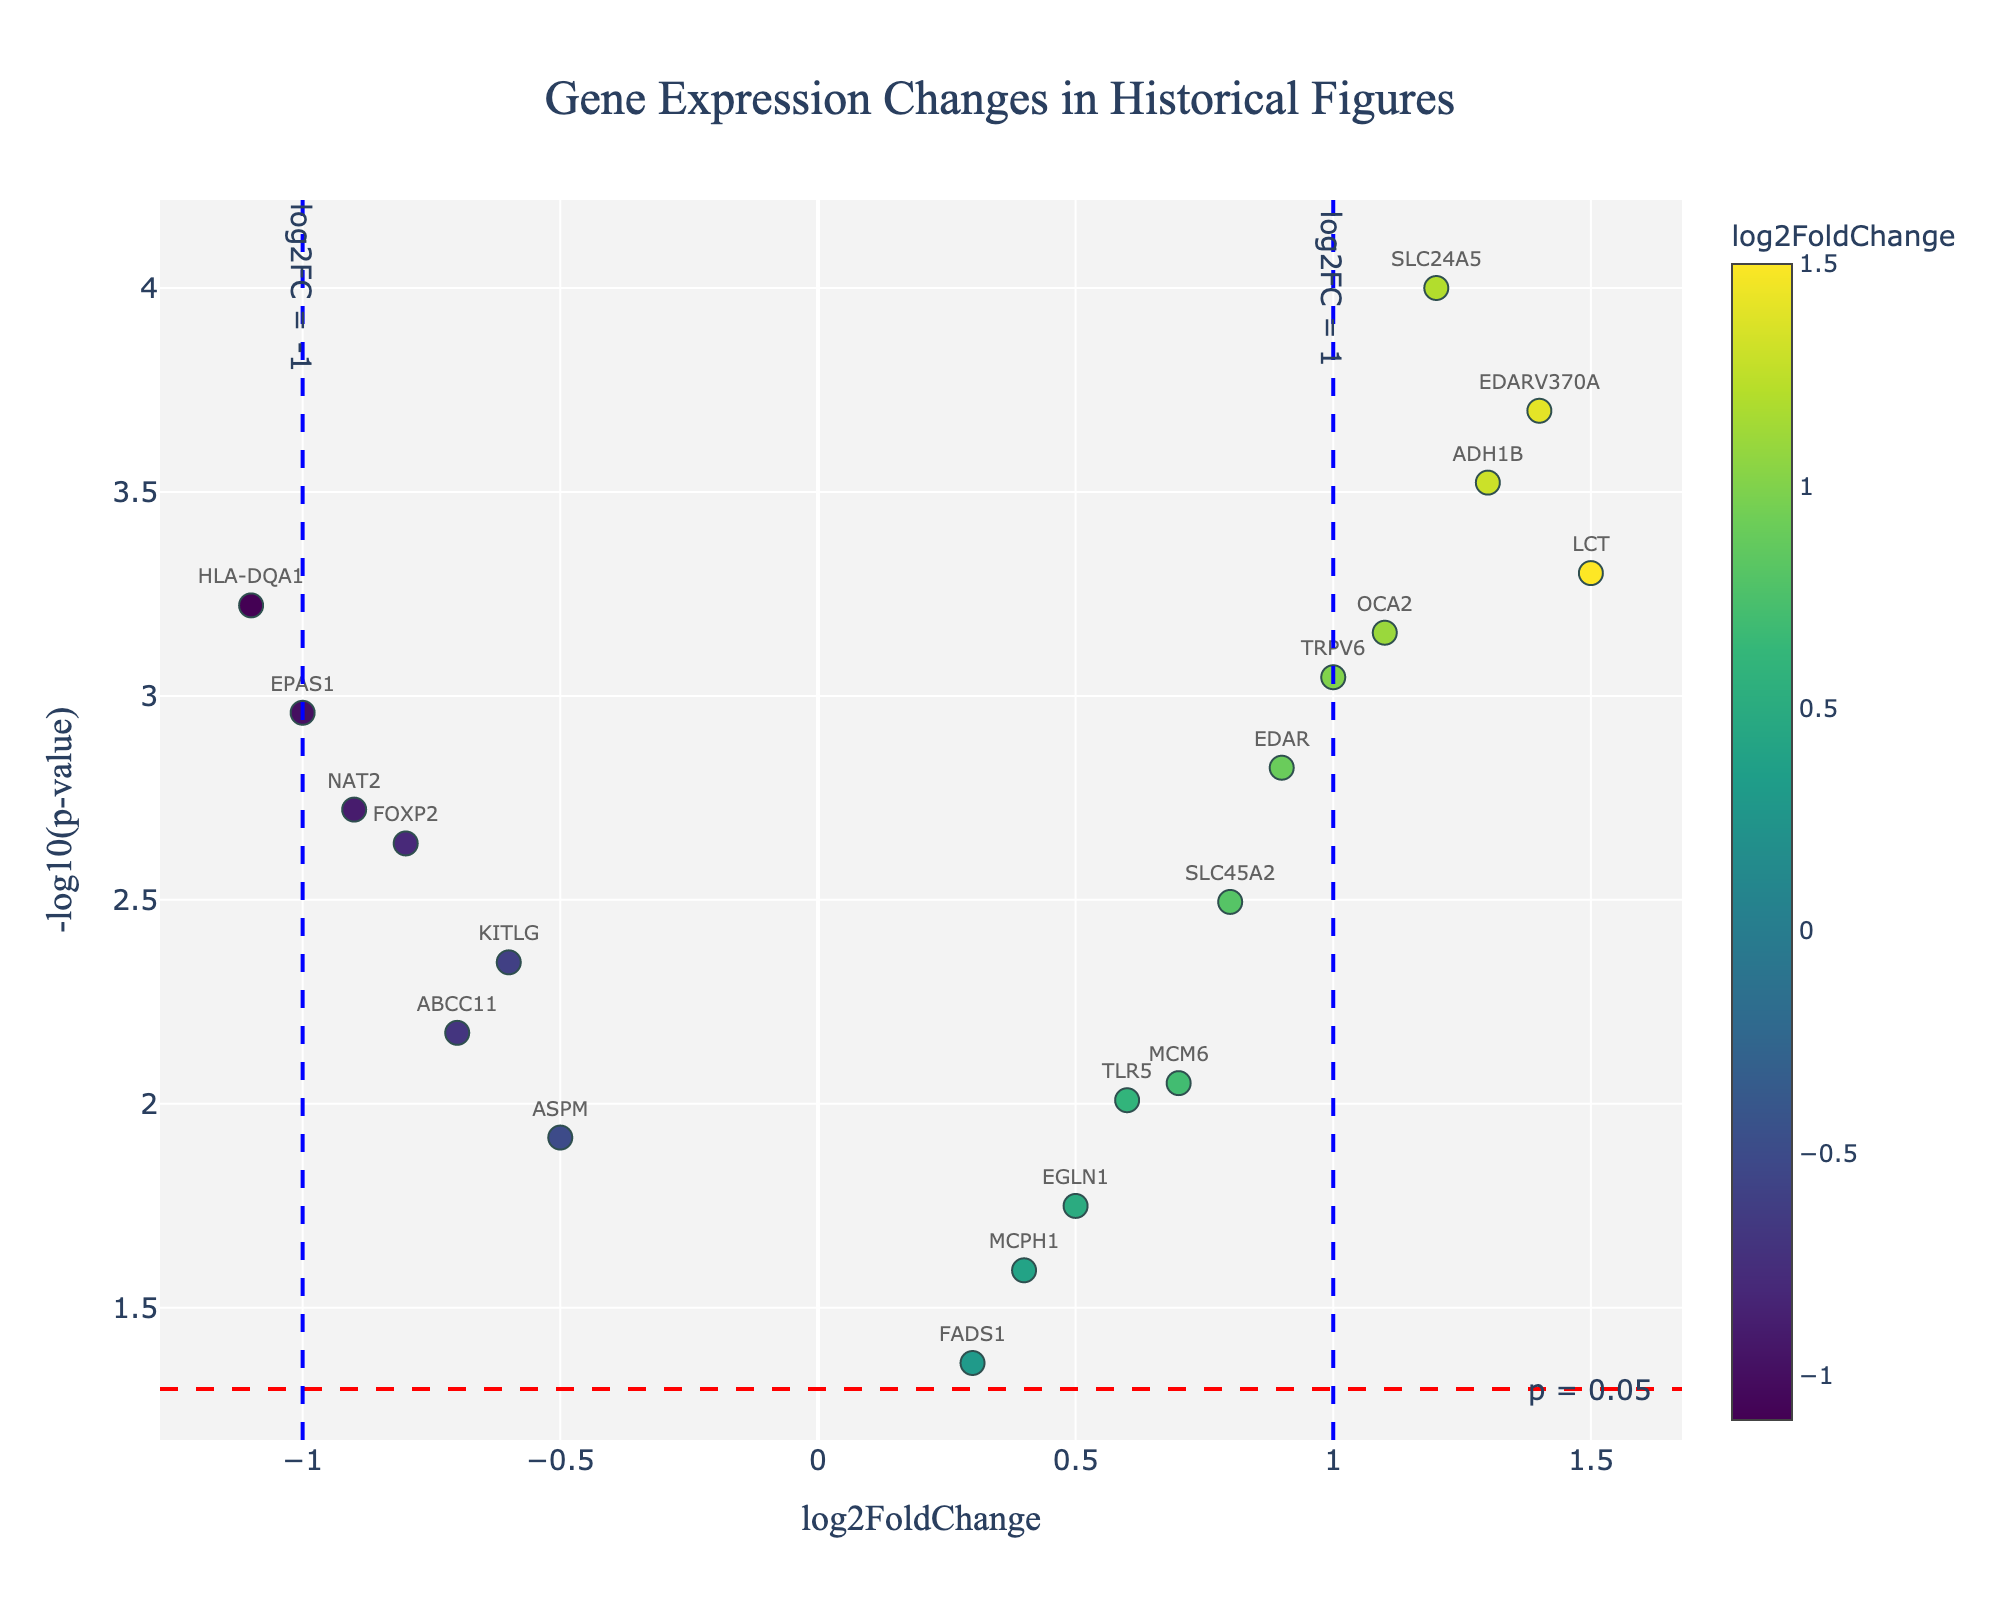What is the title of the plot? The title of the plot is shown at the very top center of the figure in a prominent font. It reads "Gene Expression Changes in Historical Figures".
Answer: Gene Expression Changes in Historical Figures What does the y-axis represent in this plot? The y-axis represents the -log10(p-value). This is shown in the axis label on the left side of the figure.
Answer: -log10(p-value) How many genes have a log2FoldChange greater than 1? To find the number of genes with a log2FoldChange > 1, look at the data points located to the right of the vertical line at x = 1. There are 4 such genes (LCT, ADH1B, EDARV370A, and SLC24A5).
Answer: 4 Which gene has the highest log2FoldChange value? The highest log2FoldChange value is 1.5, and it belongs to the gene LCT, which can be identified from the x-axis positioning and the corresponding label.
Answer: LCT Which gene exhibits the most statistically significant change (lowest p-value)? The lower the p-value, the higher its -log10(p-value) value. The gene SLC24A5 has the highest y-axis value at around 4.0, indicating it has the lowest p-value of 0.0001.
Answer: SLC24A5 What is the range of log2FoldChange for the genes shown on the plot? The range can be found by identifying the smallest and largest log2FoldChange values. The smallest is -1.1 (HLA-DQA1) and the largest is 1.5 (LCT). Thus, the range is from -1.1 to 1.5.
Answer: -1.1 to 1.5 How many genes are under the p = 0.05 significance threshold? The threshold line for p = 0.05 is shown as a horizontal red dashed line. Count the number of data points above this line. There are 15 genes above the line indicating p < 0.05.
Answer: 15 Which gene has the lowest log2FoldChange value? The lowest log2FoldChange value is -1.1, and it belongs to the gene HLA-DQA1, identifiable from the x-axis positioning and the corresponding label.
Answer: HLA-DQA1 Compare the gene FOXP2 and EPAS1. Which one has a lower p-value? Look at the y-axis values for FOXP2 and EPAS1. FOXP2 has a -log10(p-value) around 2.64, while EPAS1 has a -log10(p-value) around 3. This means EPAS1 has a lower p-value.
Answer: EPAS1 